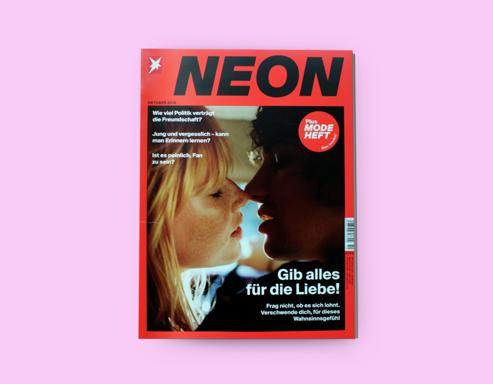Can you tell me about the color choice for the magazine cover? The magazine cover utilizes a bold pink background that demands attention and suggests a youthful, vibrant energy. This contrasts with the black text, which grounds the cover's aesthetic and ensures readability. The color pink is often associated with romance and compassion, which complements the theme of love highlighted by the cover's main headline. 